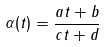<formula> <loc_0><loc_0><loc_500><loc_500>\alpha ( t ) = \frac { a t + b } { c t + d }</formula> 